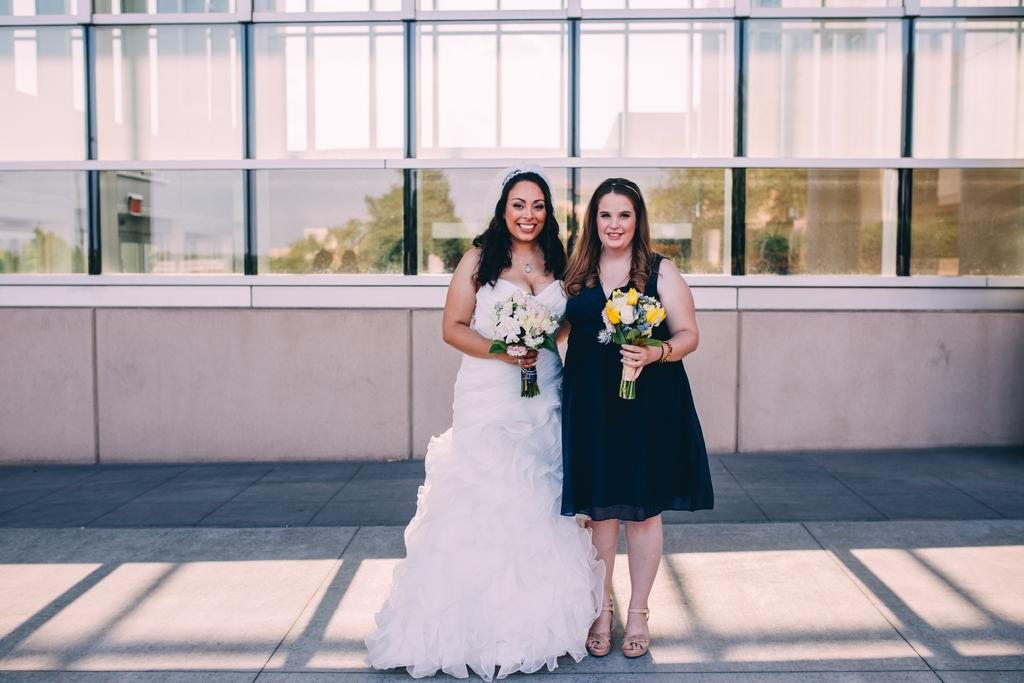How many people are in the image? There are two persons in the image. What are the persons holding in their hands? The persons are holding bouquets. What can be seen in the background of the image? There is a wall with glass windows in the background. What is visible through the glass windows? Trees and buildings are visible through the glass windows. What type of soda is being served in the image? There is no soda present in the image; it features two persons holding bouquets with a background of a wall with glass windows. What unit of measurement is used to determine the size of the bouquets in the image? The size of the bouquets cannot be determined from the image alone, and no unit of measurement is mentioned or implied. 